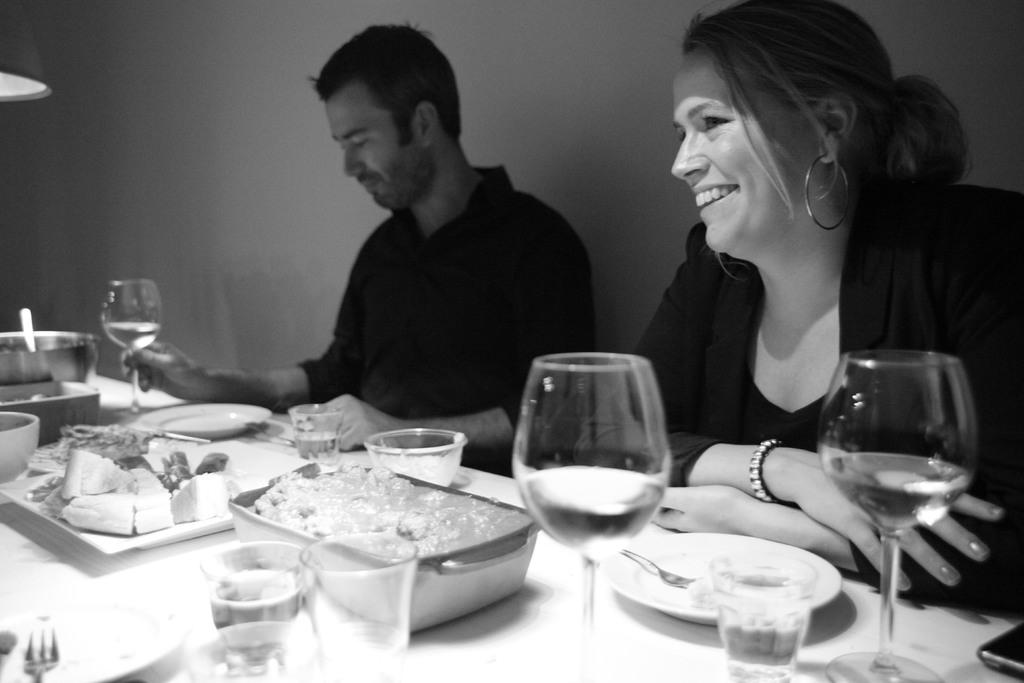How many people are seated in the image? There are two people seated in the image. What are the people seated in front of? The people are seated in front of a table. What items can be seen on the table? There are glasses, bowls, plates, and food on the table. How does the table lift the food in the image? The table does not lift the food in the image; it simply supports the food on its surface. 